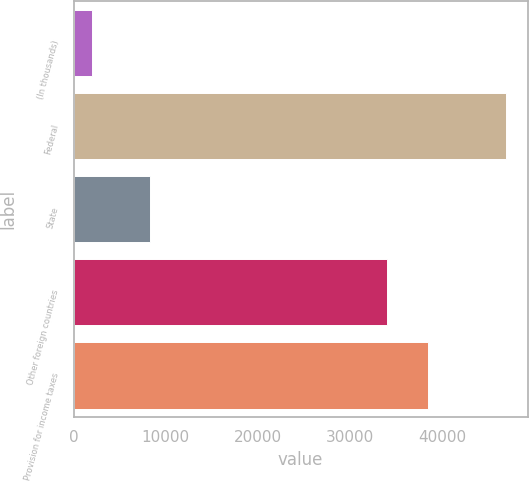<chart> <loc_0><loc_0><loc_500><loc_500><bar_chart><fcel>(In thousands)<fcel>Federal<fcel>State<fcel>Other foreign countries<fcel>Provision for income taxes<nl><fcel>2017<fcel>46931<fcel>8336<fcel>34005<fcel>38496.4<nl></chart> 